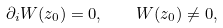Convert formula to latex. <formula><loc_0><loc_0><loc_500><loc_500>\partial _ { i } W ( z _ { 0 } ) = 0 , \quad W ( z _ { 0 } ) \ne 0 ,</formula> 